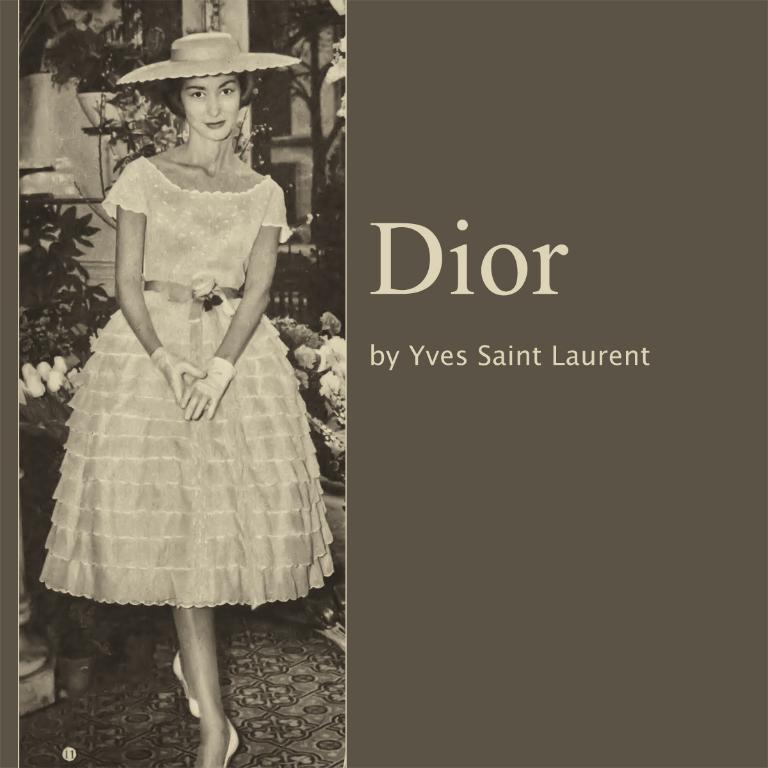<image>
Provide a brief description of the given image. The brand is by someone called Yves Saint Laurent 